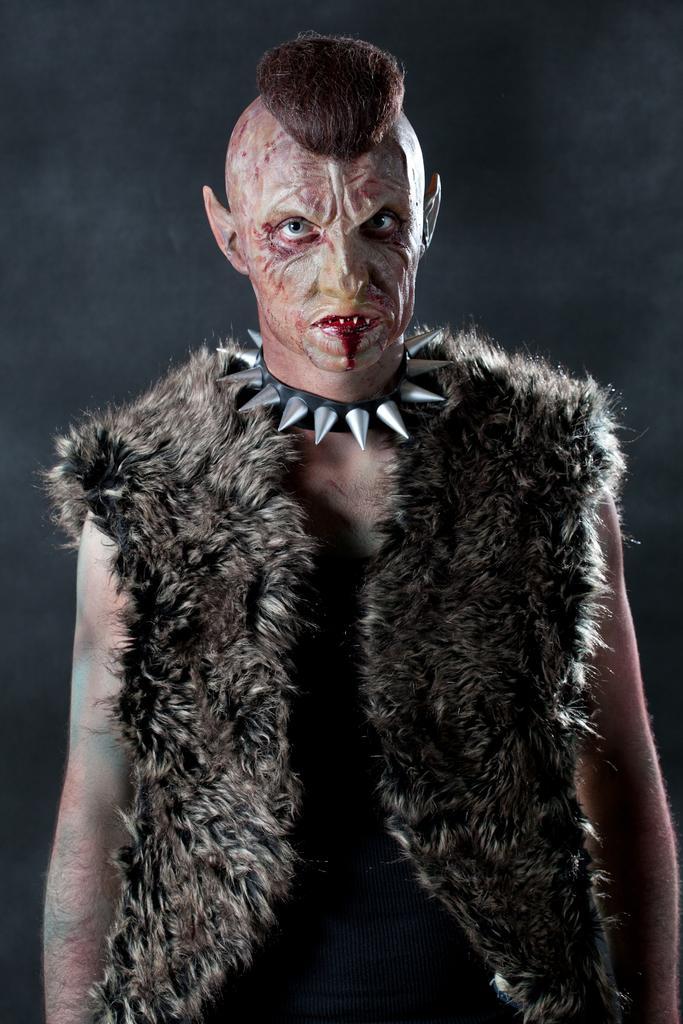In one or two sentences, can you explain what this image depicts? In this image I can see a person wearing black color dress is stunning. I can see a chain to his neck and I can see the black colored background. 